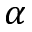Convert formula to latex. <formula><loc_0><loc_0><loc_500><loc_500>\alpha</formula> 